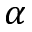Convert formula to latex. <formula><loc_0><loc_0><loc_500><loc_500>\alpha</formula> 